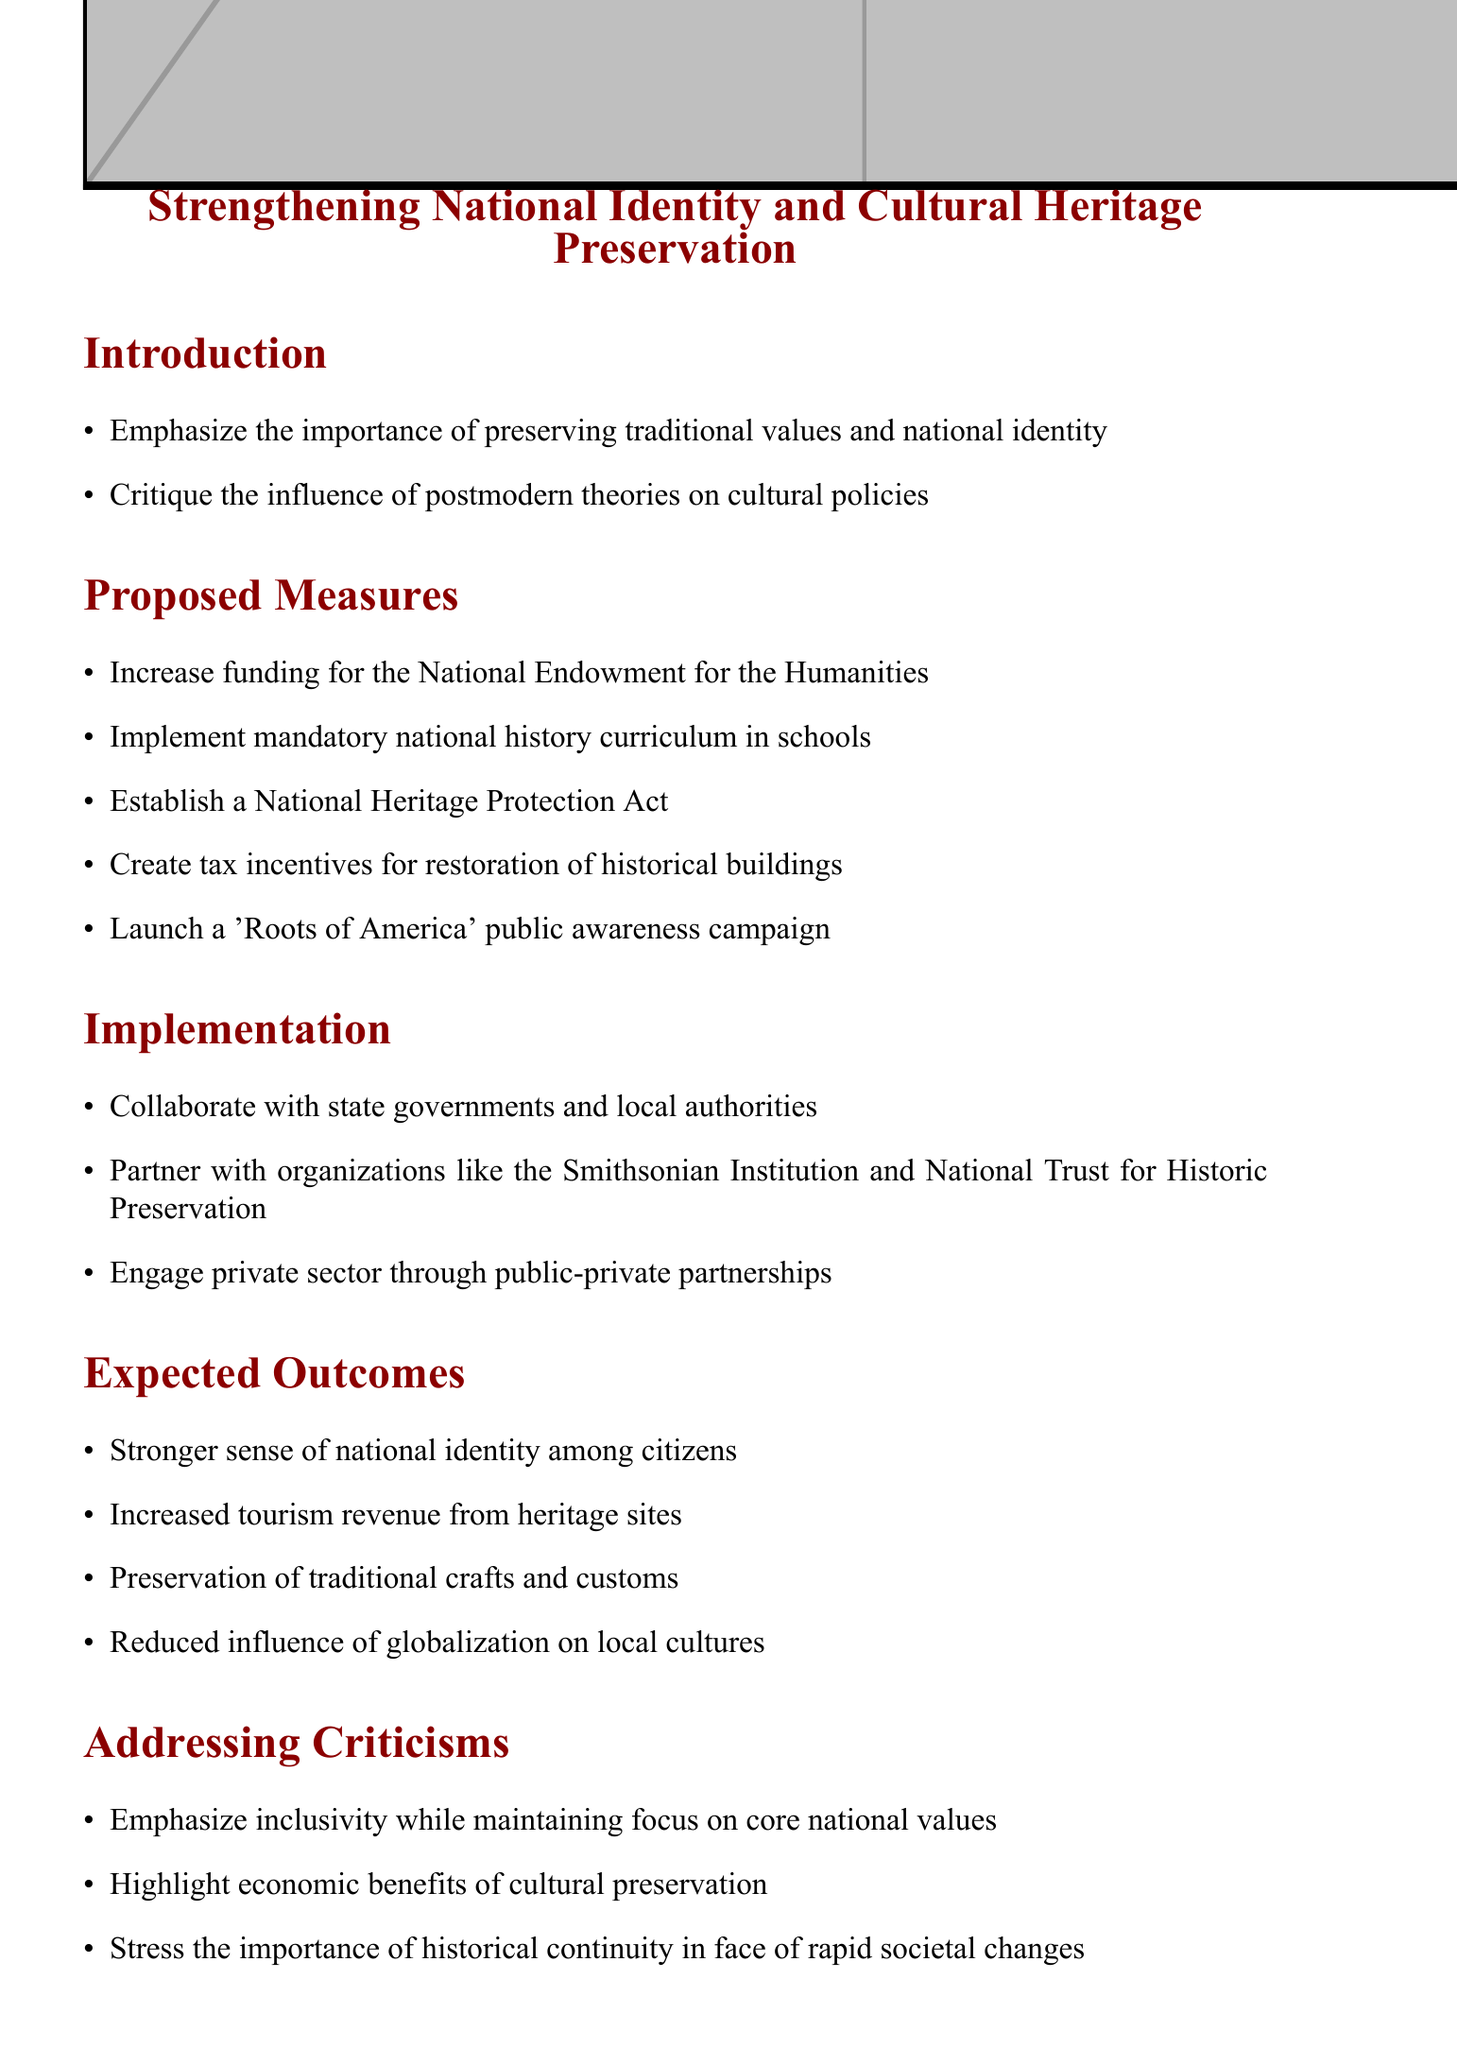What is the title of the policy proposal? The title can be found in the document's header section, which clearly states the purpose of the document.
Answer: Strengthening National Identity and Cultural Heritage Preservation What is the first proposed measure? The measures are listed in the "Proposed Measures" section, starting with the first item.
Answer: Increase funding for the National Endowment for the Humanities Which organization is suggested to partner with for implementation? The document mentions specific organizations in the "Implementation" section that could be involved in the process.
Answer: Smithsonian Institution What is one expected outcome of the policy? The expected outcomes are detailed in a specific section, offering several outcomes as a result of the policy.
Answer: Stronger sense of national identity among citizens How many proposed measures are listed in the document? Counting the items in the "Proposed Measures" section provides the number.
Answer: Five 